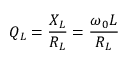Convert formula to latex. <formula><loc_0><loc_0><loc_500><loc_500>Q _ { L } = { \frac { X _ { L } } { R _ { L } } } = { \frac { \omega _ { 0 } L } { R _ { L } } }</formula> 